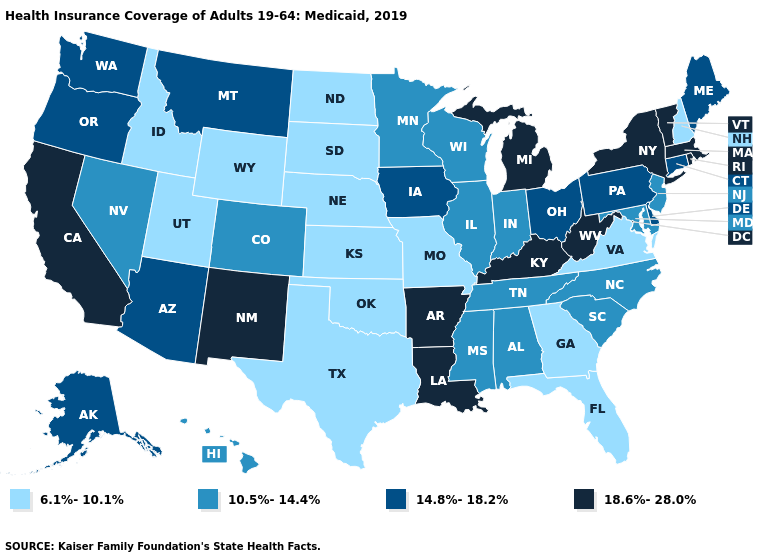Among the states that border California , which have the lowest value?
Be succinct. Nevada. Name the states that have a value in the range 18.6%-28.0%?
Answer briefly. Arkansas, California, Kentucky, Louisiana, Massachusetts, Michigan, New Mexico, New York, Rhode Island, Vermont, West Virginia. How many symbols are there in the legend?
Concise answer only. 4. Which states have the lowest value in the MidWest?
Write a very short answer. Kansas, Missouri, Nebraska, North Dakota, South Dakota. Does New Mexico have the lowest value in the USA?
Write a very short answer. No. Among the states that border New Hampshire , which have the lowest value?
Concise answer only. Maine. Does Oregon have the lowest value in the USA?
Answer briefly. No. Which states hav the highest value in the MidWest?
Concise answer only. Michigan. Does Illinois have a lower value than Hawaii?
Quick response, please. No. What is the value of Minnesota?
Short answer required. 10.5%-14.4%. What is the lowest value in states that border Vermont?
Write a very short answer. 6.1%-10.1%. Does North Carolina have the same value as Rhode Island?
Concise answer only. No. Does Colorado have the lowest value in the West?
Be succinct. No. What is the value of Connecticut?
Short answer required. 14.8%-18.2%. What is the value of Wisconsin?
Quick response, please. 10.5%-14.4%. 